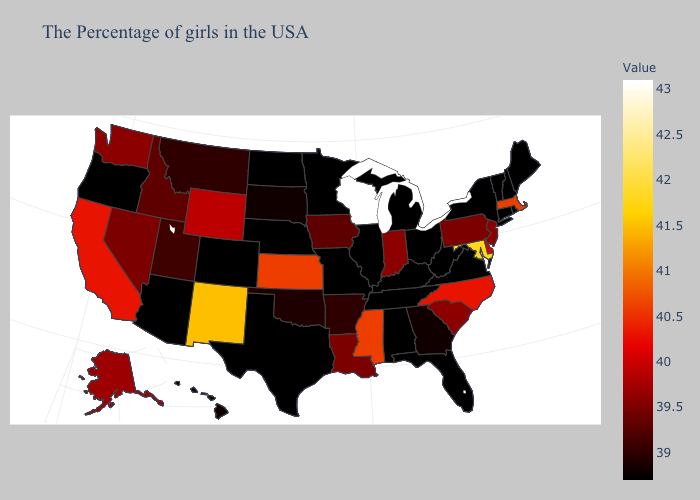Which states hav the highest value in the MidWest?
Give a very brief answer. Wisconsin. Is the legend a continuous bar?
Short answer required. Yes. Does Idaho have the highest value in the USA?
Give a very brief answer. No. Which states hav the highest value in the MidWest?
Be succinct. Wisconsin. Does South Carolina have a lower value than Wisconsin?
Concise answer only. Yes. 